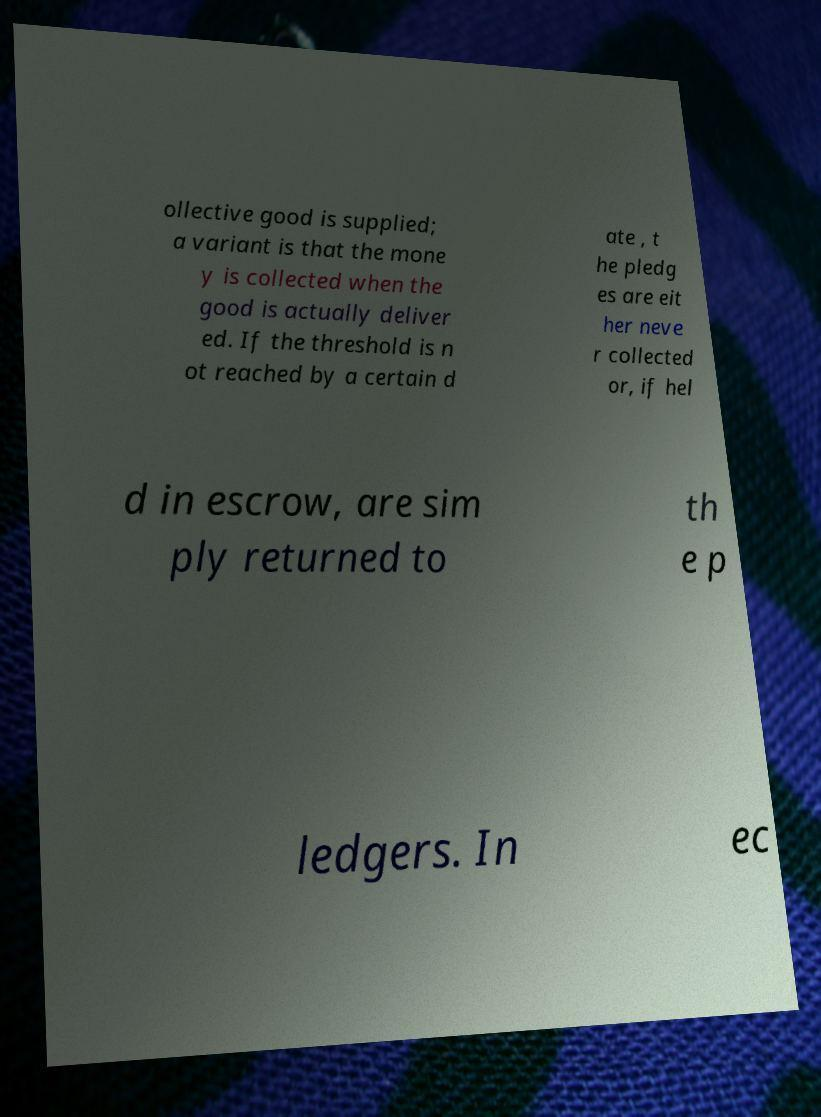Could you assist in decoding the text presented in this image and type it out clearly? ollective good is supplied; a variant is that the mone y is collected when the good is actually deliver ed. If the threshold is n ot reached by a certain d ate , t he pledg es are eit her neve r collected or, if hel d in escrow, are sim ply returned to th e p ledgers. In ec 